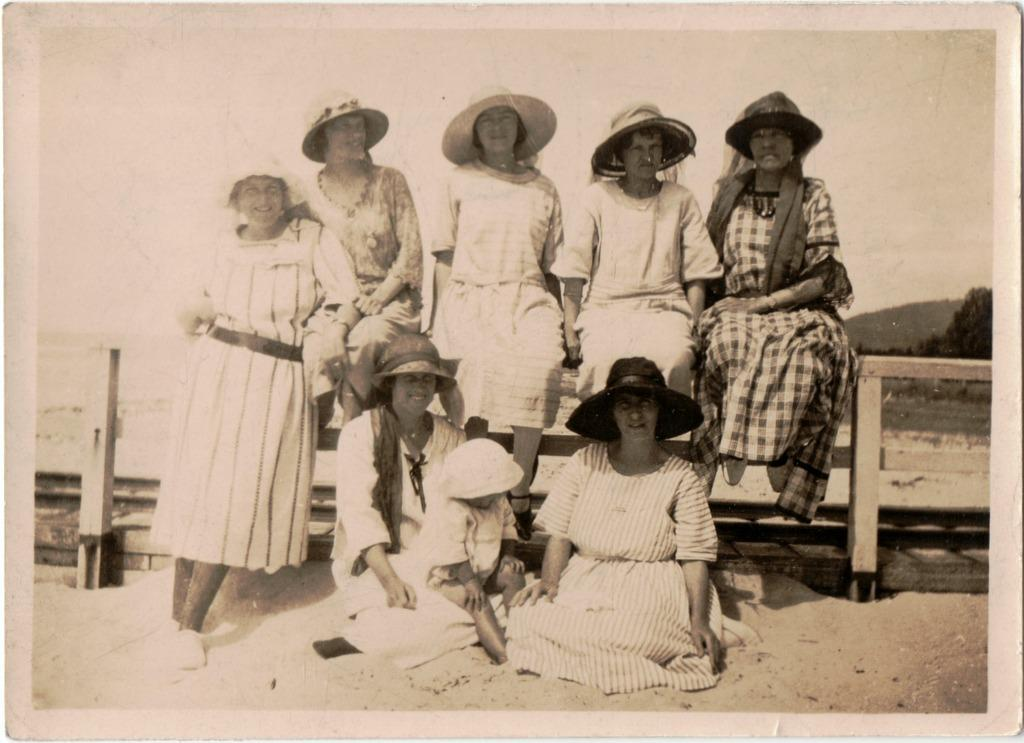What is the color scheme of the image? The image is black and white. What are the people in the image wearing on their heads? There are people wearing hats in the image. How many people are sitting on the fence in the image? There are four people sitting on a fence in the image. What type of disgust can be seen on the faces of the people sitting on the fence in the image? There is no indication of disgust on the faces of the people in the image; they are simply sitting on the fence. 